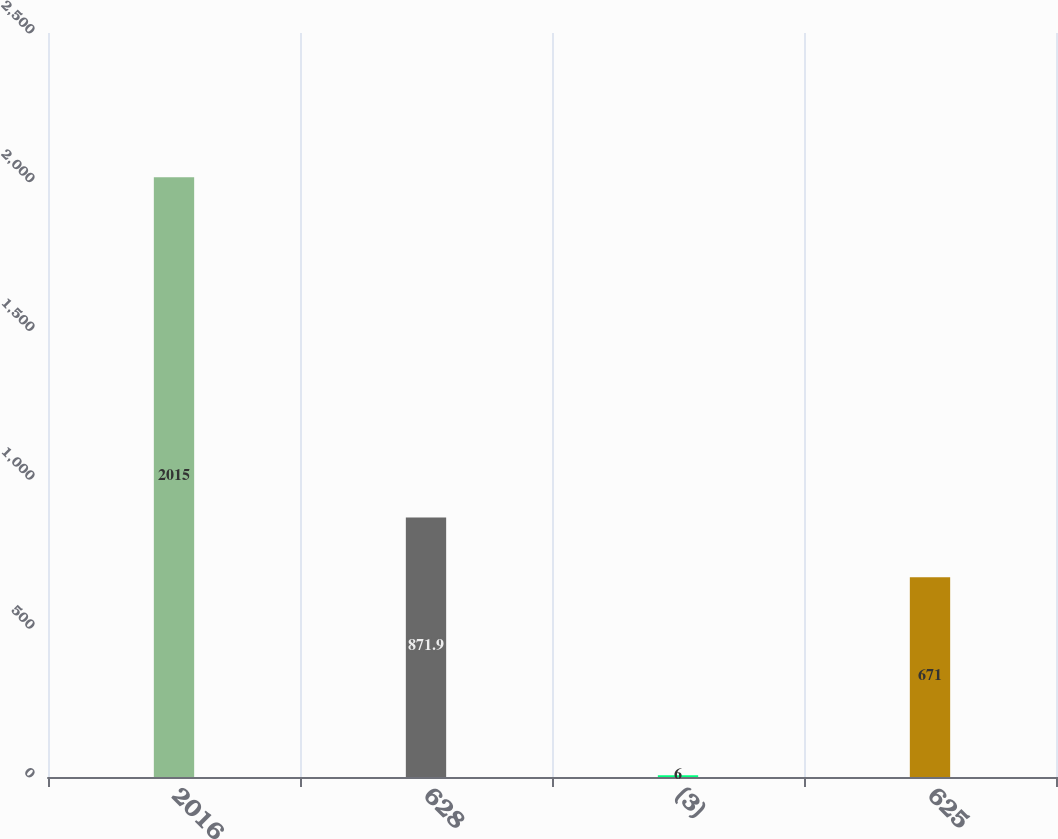<chart> <loc_0><loc_0><loc_500><loc_500><bar_chart><fcel>2016<fcel>628<fcel>(3)<fcel>625<nl><fcel>2015<fcel>871.9<fcel>6<fcel>671<nl></chart> 